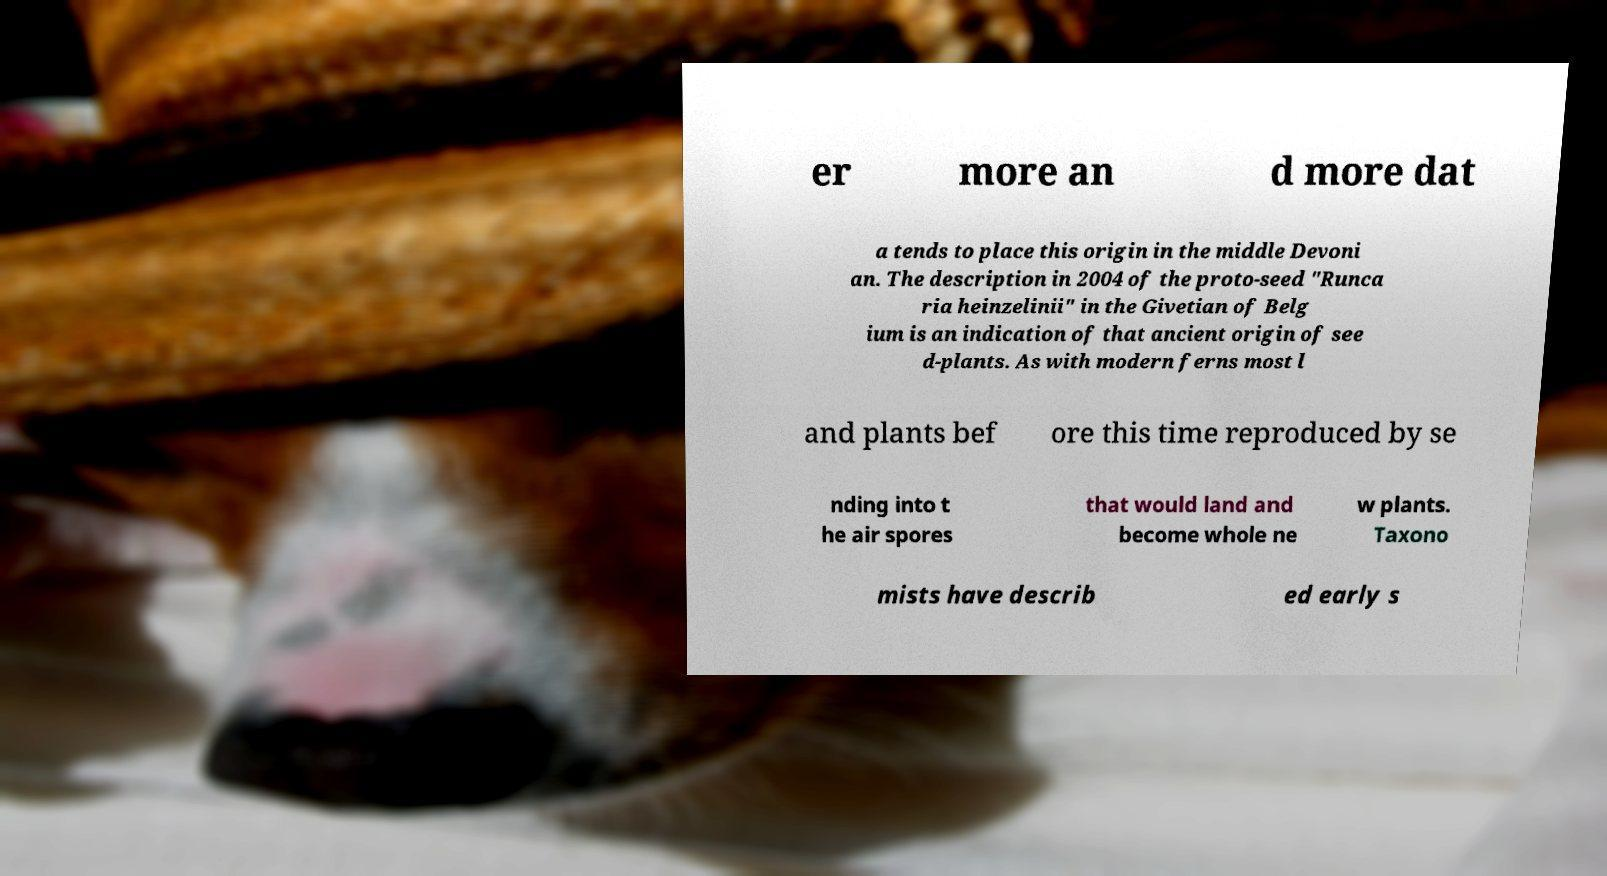There's text embedded in this image that I need extracted. Can you transcribe it verbatim? er more an d more dat a tends to place this origin in the middle Devoni an. The description in 2004 of the proto-seed "Runca ria heinzelinii" in the Givetian of Belg ium is an indication of that ancient origin of see d-plants. As with modern ferns most l and plants bef ore this time reproduced by se nding into t he air spores that would land and become whole ne w plants. Taxono mists have describ ed early s 